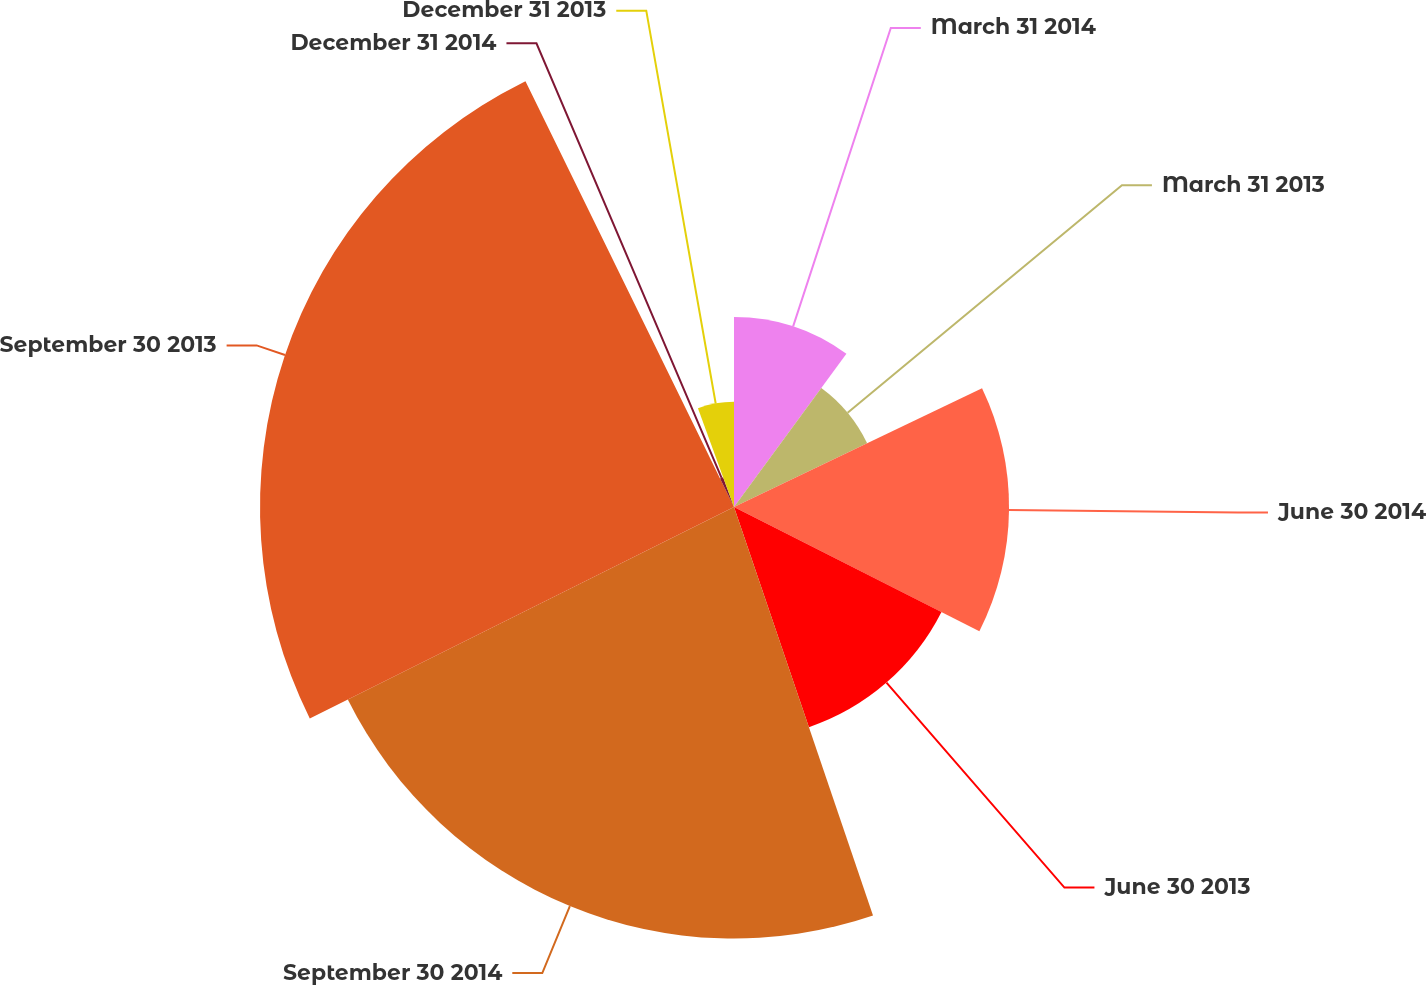Convert chart to OTSL. <chart><loc_0><loc_0><loc_500><loc_500><pie_chart><fcel>March 31 2014<fcel>March 31 2013<fcel>June 30 2014<fcel>June 30 2013<fcel>September 30 2014<fcel>September 30 2013<fcel>December 31 2014<fcel>December 31 2013<nl><fcel>10.07%<fcel>7.82%<fcel>14.57%<fcel>12.32%<fcel>22.86%<fcel>25.11%<fcel>1.68%<fcel>5.57%<nl></chart> 